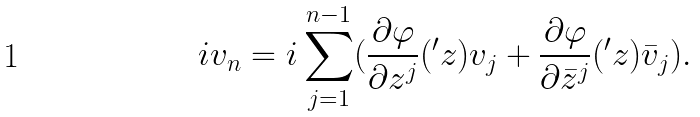Convert formula to latex. <formula><loc_0><loc_0><loc_500><loc_500>i v _ { n } = i \sum _ { j = 1 } ^ { n - 1 } ( \frac { \partial \varphi } { \partial z ^ { j } } ( ^ { \prime } z ) v _ { j } + \frac { \partial \varphi } { \partial \bar { z } ^ { j } } ( ^ { \prime } z ) \bar { v } _ { j } ) .</formula> 